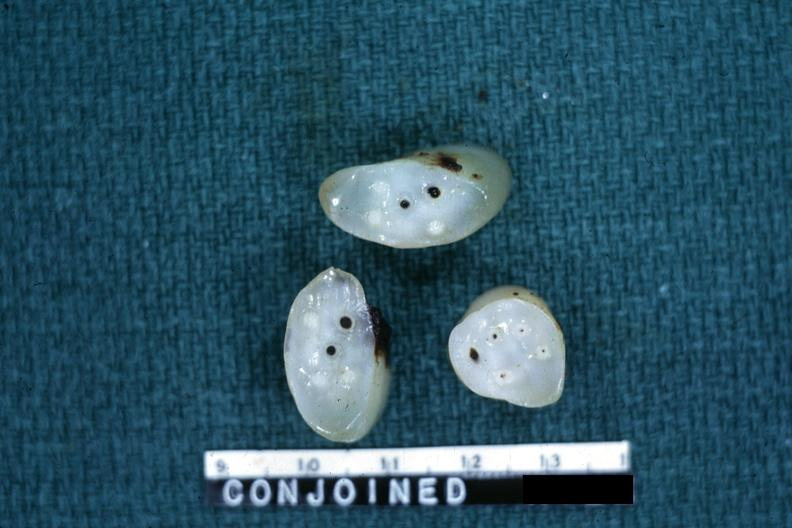s intraductal lesions present?
Answer the question using a single word or phrase. No 